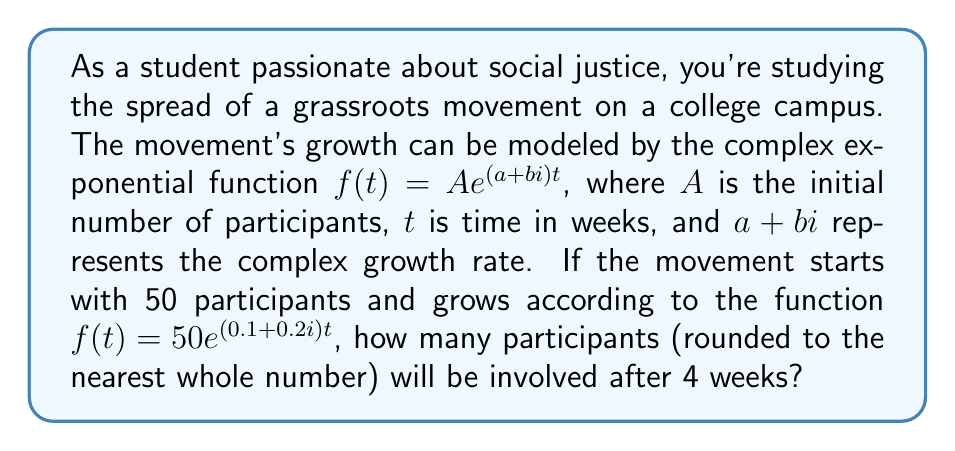Provide a solution to this math problem. Let's approach this step-by-step:

1) We're given the function $f(t) = 50 e^{(0.1+0.2i)t}$

2) We need to find $f(4)$ since we're interested in the number of participants after 4 weeks.

3) Let's substitute $t=4$ into our function:

   $f(4) = 50 e^{(0.1+0.2i)4}$

4) Simplify the exponent:
   
   $f(4) = 50 e^{0.4+0.8i}$

5) To evaluate this, we can use Euler's formula: $e^{x+yi} = e^x(\cos y + i\sin y)$

6) In our case, $x=0.4$ and $y=0.8$:

   $f(4) = 50 e^{0.4}(\cos 0.8 + i\sin 0.8)$

7) Let's evaluate each part:
   
   $e^{0.4} \approx 1.4918$
   $\cos 0.8 \approx 0.6967$
   $\sin 0.8 \approx 0.7174$

8) Substituting these values:

   $f(4) \approx 50 \cdot 1.4918 (0.6967 + 0.7174i)$

9) Multiply:

   $f(4) \approx 74.59 (0.6967 + 0.7174i)$

10) The real part of this complex number represents the actual number of participants:

    $74.59 \cdot 0.6967 \approx 51.97$

11) Rounding to the nearest whole number:

    $52$
Answer: 52 participants 